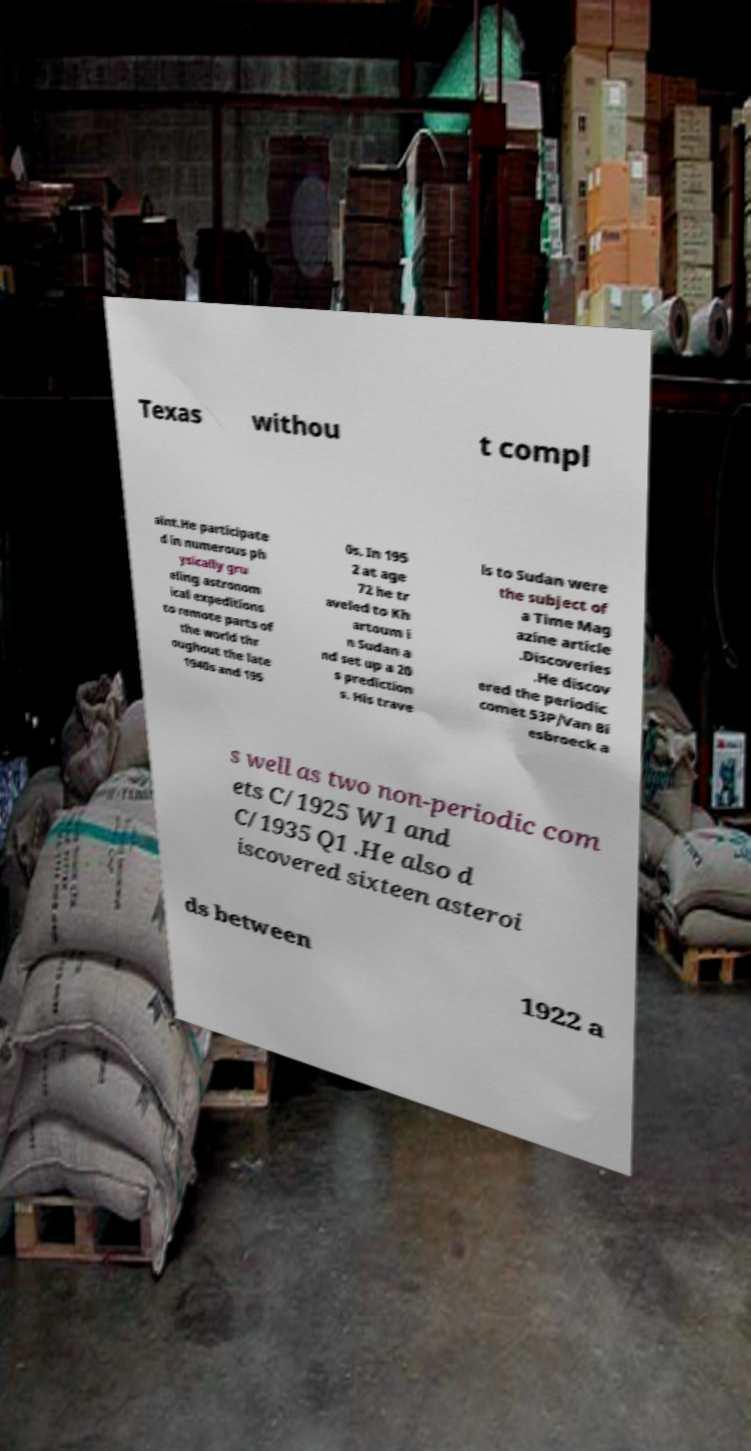Can you read and provide the text displayed in the image?This photo seems to have some interesting text. Can you extract and type it out for me? Texas withou t compl aint.He participate d in numerous ph ysically gru eling astronom ical expeditions to remote parts of the world thr oughout the late 1940s and 195 0s. In 195 2 at age 72 he tr aveled to Kh artoum i n Sudan a nd set up a 20 s prediction s. His trave ls to Sudan were the subject of a Time Mag azine article .Discoveries .He discov ered the periodic comet 53P/Van Bi esbroeck a s well as two non-periodic com ets C/1925 W1 and C/1935 Q1 .He also d iscovered sixteen asteroi ds between 1922 a 